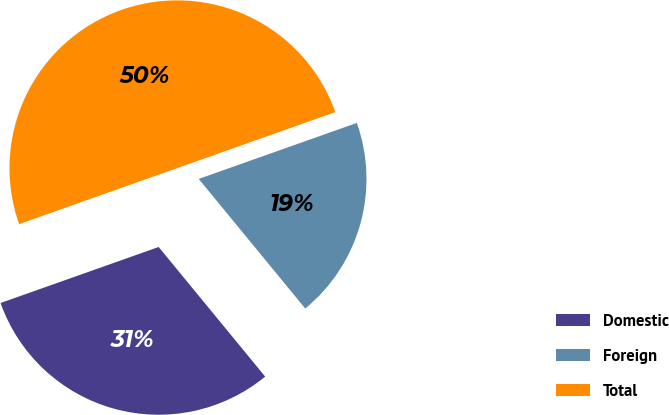Convert chart. <chart><loc_0><loc_0><loc_500><loc_500><pie_chart><fcel>Domestic<fcel>Foreign<fcel>Total<nl><fcel>30.53%<fcel>19.47%<fcel>50.0%<nl></chart> 